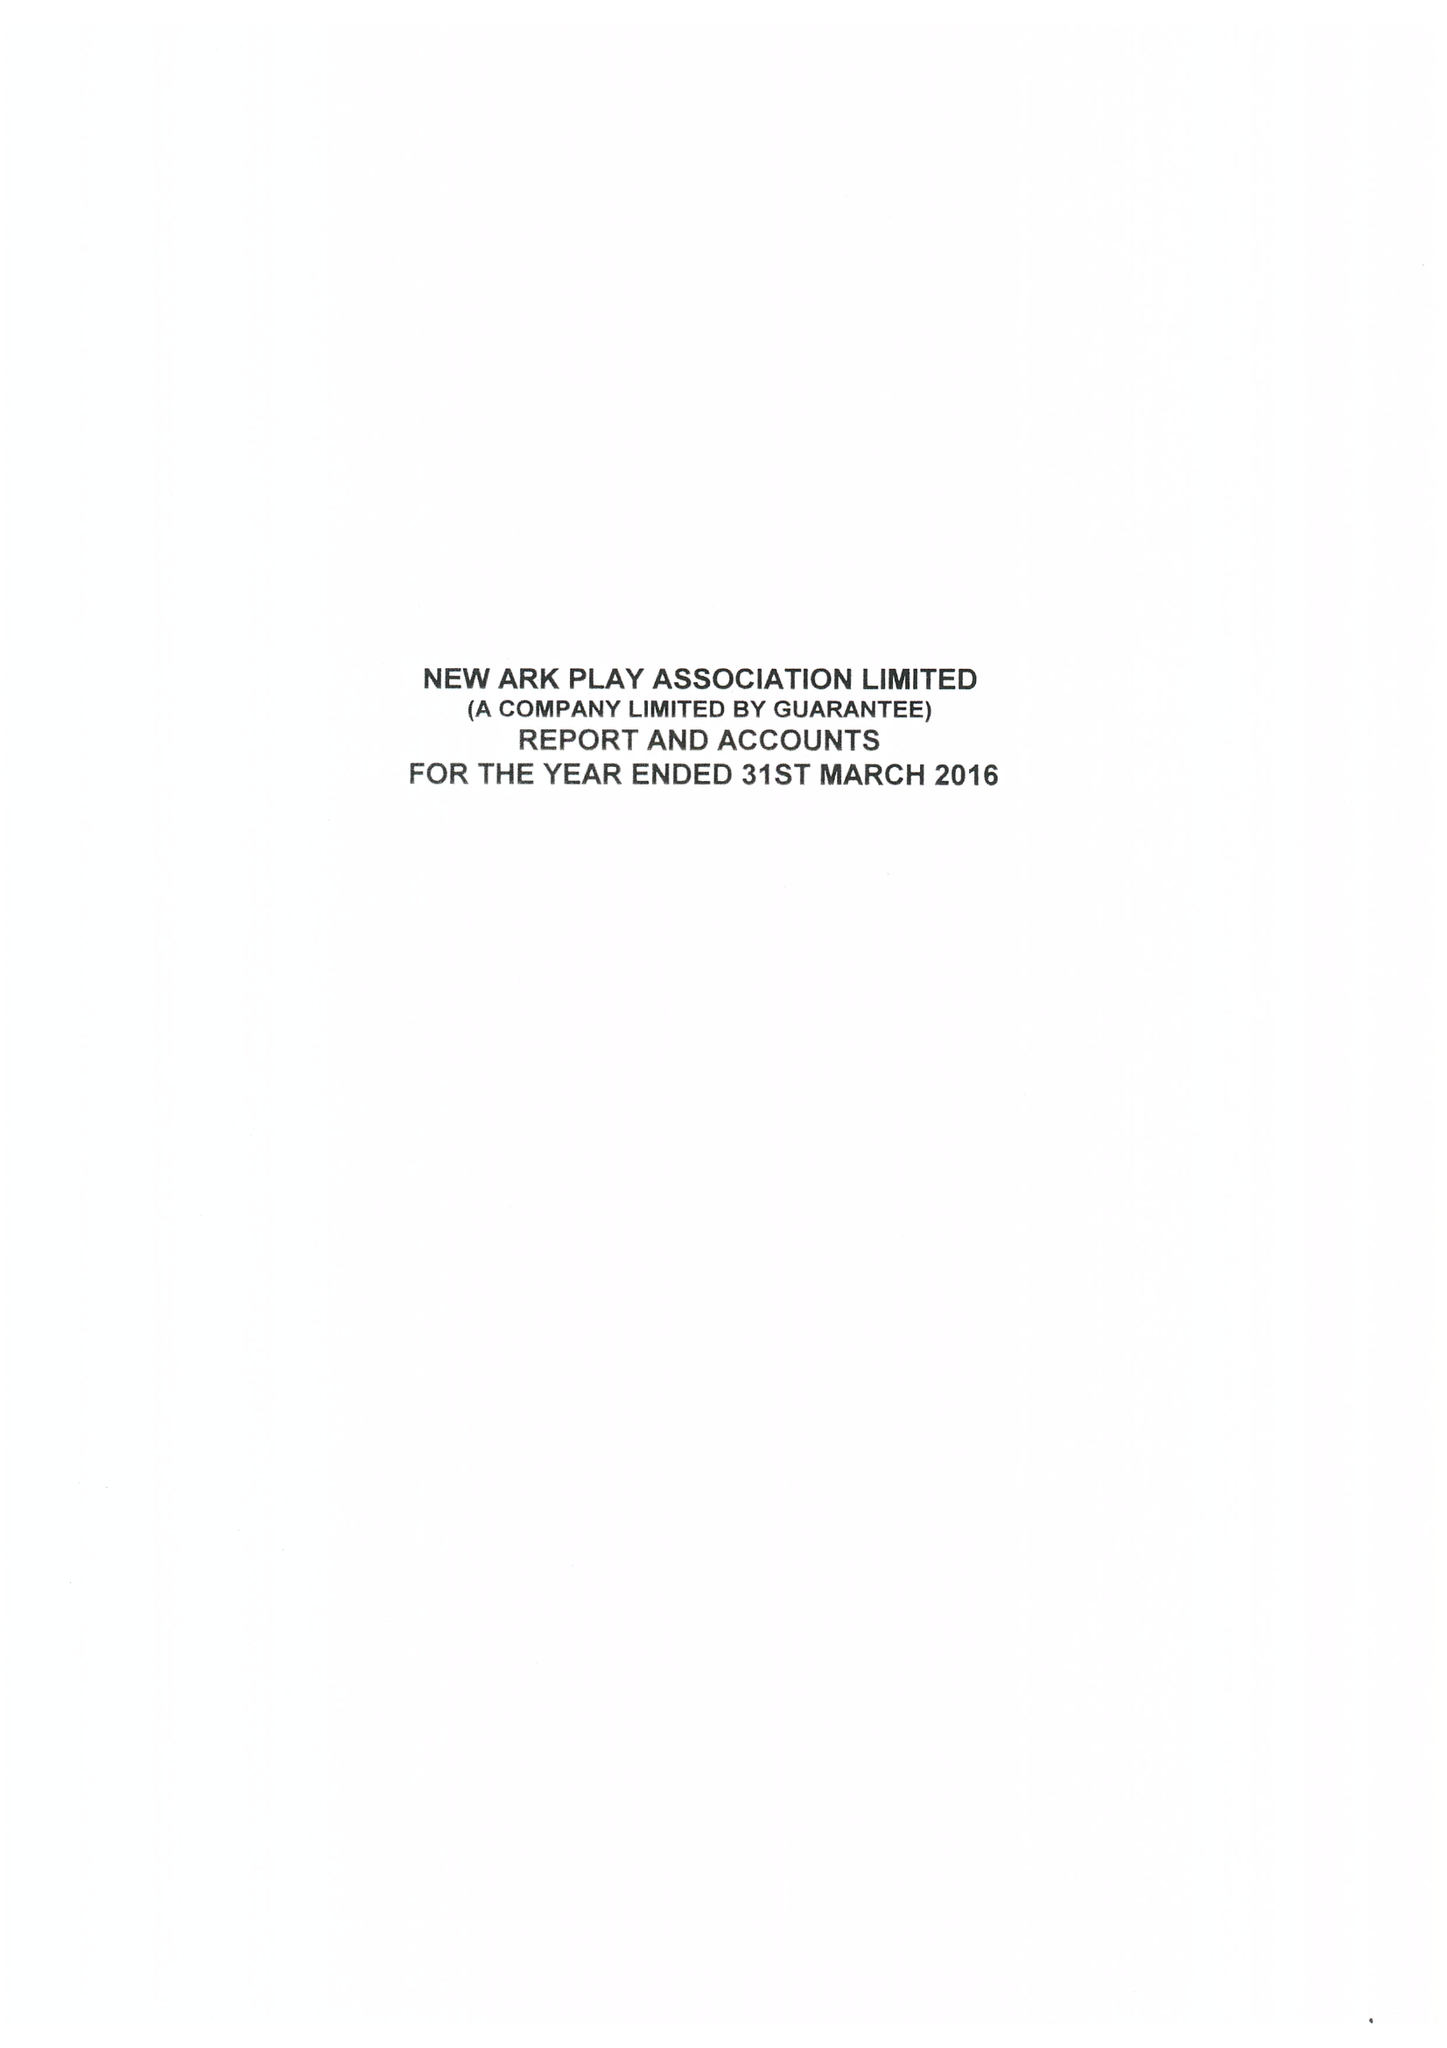What is the value for the spending_annually_in_british_pounds?
Answer the question using a single word or phrase. 270944.00 